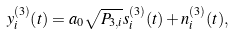<formula> <loc_0><loc_0><loc_500><loc_500>y _ { i } ^ { ( 3 ) } ( t ) = a _ { 0 } \sqrt { P _ { 3 , i } } s _ { i } ^ { ( 3 ) } ( t ) + n _ { i } ^ { ( 3 ) } ( t ) ,</formula> 